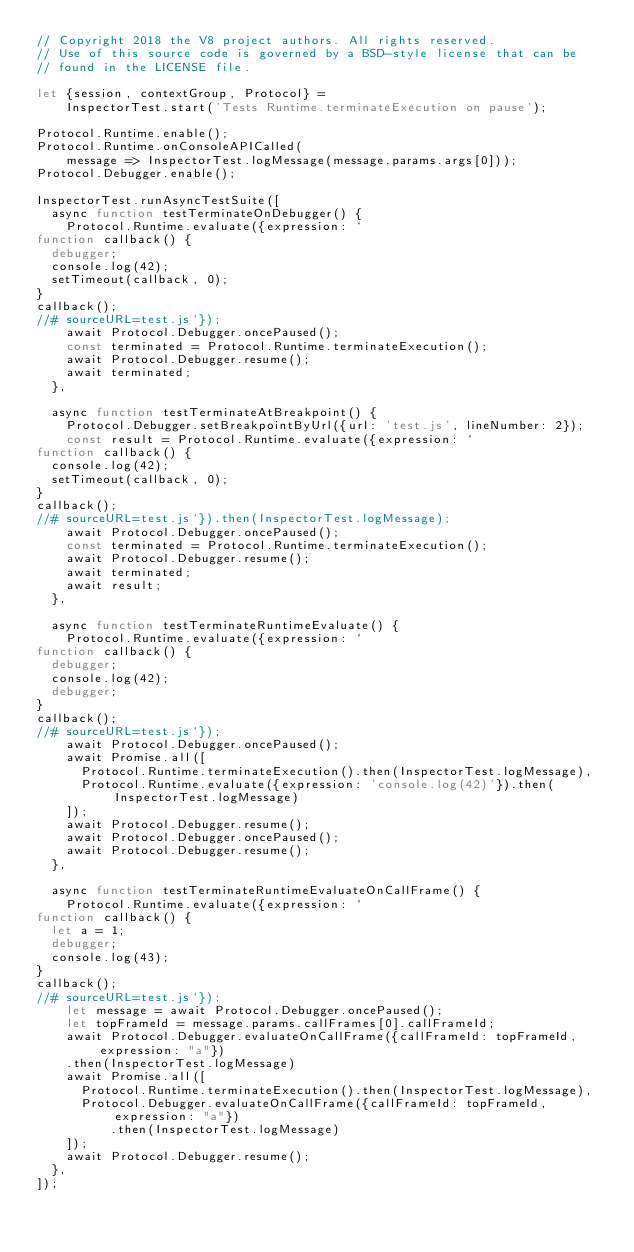<code> <loc_0><loc_0><loc_500><loc_500><_JavaScript_>// Copyright 2018 the V8 project authors. All rights reserved.
// Use of this source code is governed by a BSD-style license that can be
// found in the LICENSE file.

let {session, contextGroup, Protocol} =
    InspectorTest.start('Tests Runtime.terminateExecution on pause');

Protocol.Runtime.enable();
Protocol.Runtime.onConsoleAPICalled(
    message => InspectorTest.logMessage(message.params.args[0]));
Protocol.Debugger.enable();

InspectorTest.runAsyncTestSuite([
  async function testTerminateOnDebugger() {
    Protocol.Runtime.evaluate({expression: `
function callback() {
  debugger;
  console.log(42);
  setTimeout(callback, 0);
}
callback();
//# sourceURL=test.js`});
    await Protocol.Debugger.oncePaused();
    const terminated = Protocol.Runtime.terminateExecution();
    await Protocol.Debugger.resume();
    await terminated;
  },

  async function testTerminateAtBreakpoint() {
    Protocol.Debugger.setBreakpointByUrl({url: 'test.js', lineNumber: 2});
    const result = Protocol.Runtime.evaluate({expression: `
function callback() {
  console.log(42);
  setTimeout(callback, 0);
}
callback();
//# sourceURL=test.js`}).then(InspectorTest.logMessage);
    await Protocol.Debugger.oncePaused();
    const terminated = Protocol.Runtime.terminateExecution();
    await Protocol.Debugger.resume();
    await terminated;
    await result;
  },

  async function testTerminateRuntimeEvaluate() {
    Protocol.Runtime.evaluate({expression: `
function callback() {
  debugger;
  console.log(42);
  debugger;
}
callback();
//# sourceURL=test.js`});
    await Protocol.Debugger.oncePaused();
    await Promise.all([
      Protocol.Runtime.terminateExecution().then(InspectorTest.logMessage),
      Protocol.Runtime.evaluate({expression: 'console.log(42)'}).then(InspectorTest.logMessage)
    ]);
    await Protocol.Debugger.resume();
    await Protocol.Debugger.oncePaused();
    await Protocol.Debugger.resume();
  },

  async function testTerminateRuntimeEvaluateOnCallFrame() {
    Protocol.Runtime.evaluate({expression: `
function callback() {
  let a = 1;
  debugger;
  console.log(43);
}
callback();
//# sourceURL=test.js`});
    let message = await Protocol.Debugger.oncePaused();
    let topFrameId = message.params.callFrames[0].callFrameId;
    await Protocol.Debugger.evaluateOnCallFrame({callFrameId: topFrameId, expression: "a"})
    .then(InspectorTest.logMessage)
    await Promise.all([
      Protocol.Runtime.terminateExecution().then(InspectorTest.logMessage),
      Protocol.Debugger.evaluateOnCallFrame({callFrameId: topFrameId, expression: "a"})
          .then(InspectorTest.logMessage)
    ]);
    await Protocol.Debugger.resume();
  },
]);
</code> 